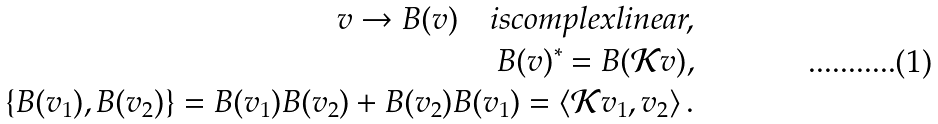Convert formula to latex. <formula><loc_0><loc_0><loc_500><loc_500>v \to B ( v ) \quad i s c o m p l e x l i n e a r , \\ B ( v ) ^ { * } = B ( \mathcal { K } v ) , \\ \{ B ( v _ { 1 } ) , B ( v _ { 2 } ) \} = B ( v _ { 1 } ) B ( v _ { 2 } ) + B ( v _ { 2 } ) B ( v _ { 1 } ) = \langle \mathcal { K } v _ { 1 } , v _ { 2 } \rangle \, .</formula> 